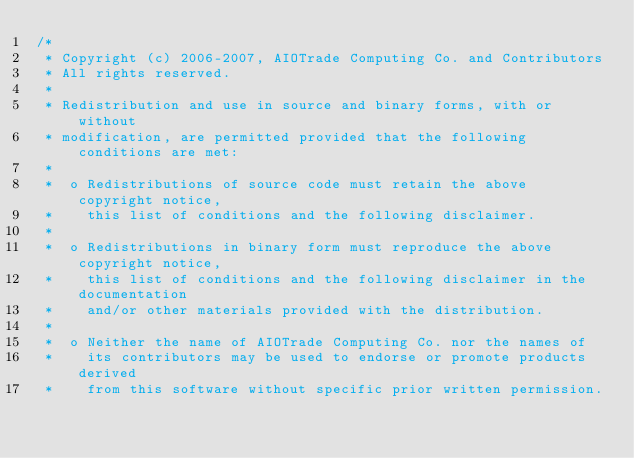Convert code to text. <code><loc_0><loc_0><loc_500><loc_500><_Scala_>/*
 * Copyright (c) 2006-2007, AIOTrade Computing Co. and Contributors
 * All rights reserved.
 * 
 * Redistribution and use in source and binary forms, with or without 
 * modification, are permitted provided that the following conditions are met:
 * 
 *  o Redistributions of source code must retain the above copyright notice, 
 *    this list of conditions and the following disclaimer. 
 *    
 *  o Redistributions in binary form must reproduce the above copyright notice, 
 *    this list of conditions and the following disclaimer in the documentation 
 *    and/or other materials provided with the distribution. 
 *    
 *  o Neither the name of AIOTrade Computing Co. nor the names of 
 *    its contributors may be used to endorse or promote products derived 
 *    from this software without specific prior written permission. </code> 